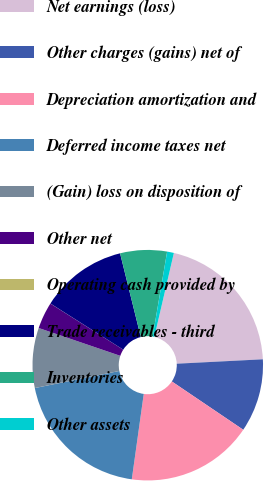Convert chart to OTSL. <chart><loc_0><loc_0><loc_500><loc_500><pie_chart><fcel>Net earnings (loss)<fcel>Other charges (gains) net of<fcel>Depreciation amortization and<fcel>Deferred income taxes net<fcel>(Gain) loss on disposition of<fcel>Other net<fcel>Operating cash provided by<fcel>Trade receivables - third<fcel>Inventories<fcel>Other assets<nl><fcel>20.55%<fcel>10.28%<fcel>17.75%<fcel>19.61%<fcel>8.41%<fcel>3.75%<fcel>0.01%<fcel>12.15%<fcel>6.55%<fcel>0.95%<nl></chart> 